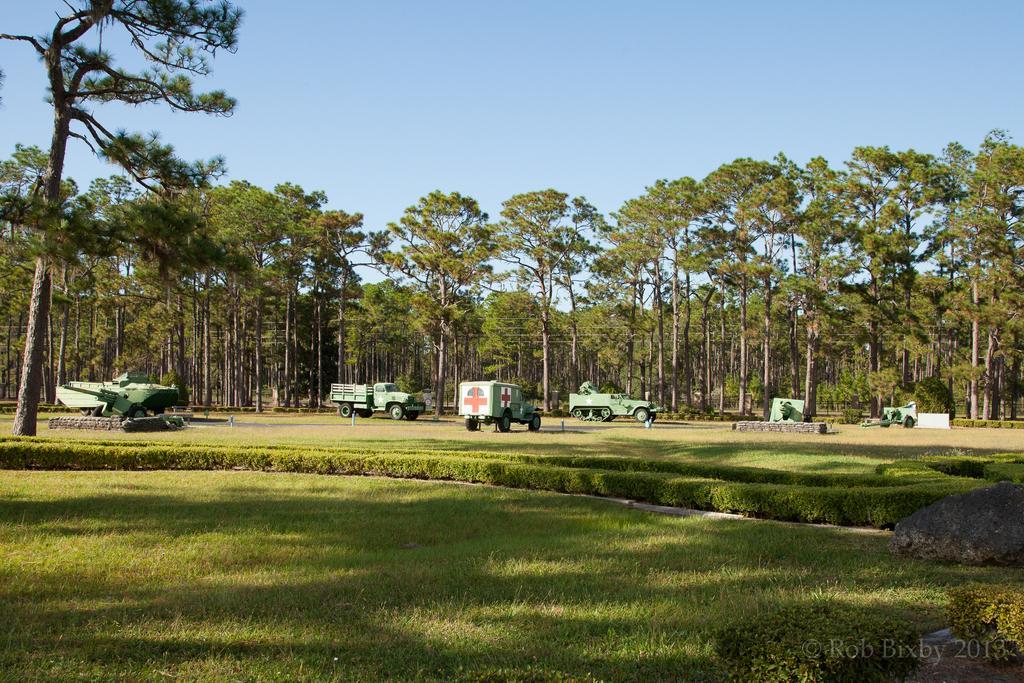Please provide a concise description of this image. In this picture we can see grass, bushes, vehicles, trees and a few things. We can see the sky. There is a watermark, some text and numbers visible in the bottom right. 